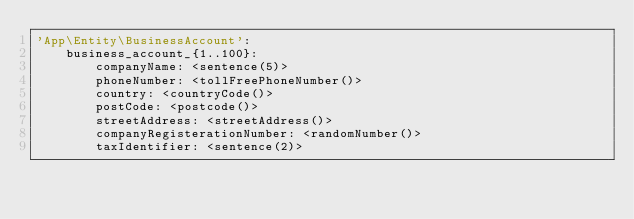<code> <loc_0><loc_0><loc_500><loc_500><_YAML_>'App\Entity\BusinessAccount':
    business_account_{1..100}:
        companyName: <sentence(5)>
        phoneNumber: <tollFreePhoneNumber()>
        country: <countryCode()>
        postCode: <postcode()>
        streetAddress: <streetAddress()> 
        companyRegisterationNumber: <randomNumber()>
        taxIdentifier: <sentence(2)></code> 